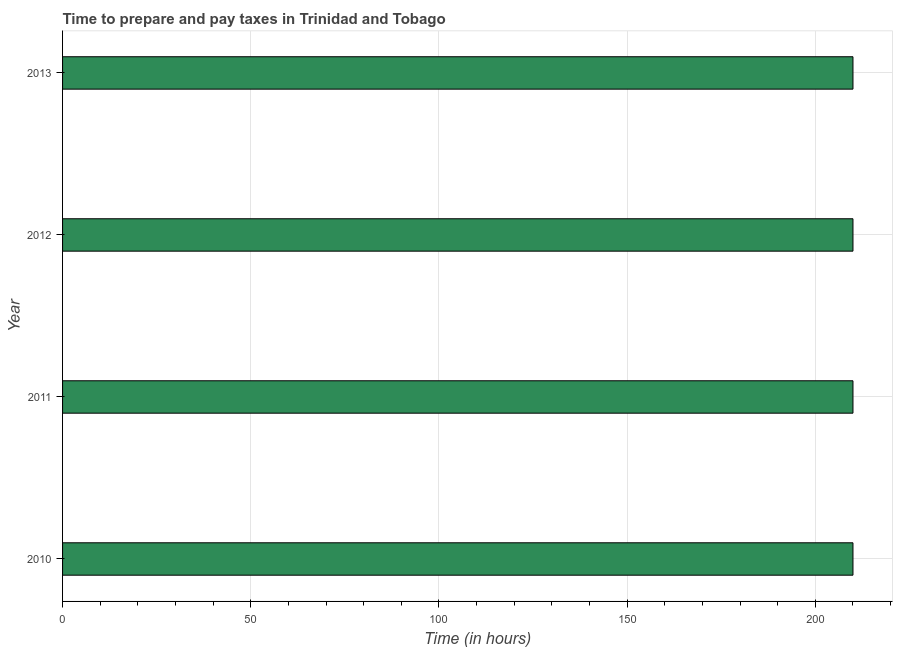Does the graph contain any zero values?
Keep it short and to the point. No. Does the graph contain grids?
Provide a short and direct response. Yes. What is the title of the graph?
Ensure brevity in your answer.  Time to prepare and pay taxes in Trinidad and Tobago. What is the label or title of the X-axis?
Ensure brevity in your answer.  Time (in hours). What is the label or title of the Y-axis?
Provide a succinct answer. Year. What is the time to prepare and pay taxes in 2012?
Make the answer very short. 210. Across all years, what is the maximum time to prepare and pay taxes?
Give a very brief answer. 210. Across all years, what is the minimum time to prepare and pay taxes?
Keep it short and to the point. 210. In which year was the time to prepare and pay taxes maximum?
Give a very brief answer. 2010. In which year was the time to prepare and pay taxes minimum?
Keep it short and to the point. 2010. What is the sum of the time to prepare and pay taxes?
Provide a short and direct response. 840. What is the difference between the time to prepare and pay taxes in 2011 and 2012?
Your response must be concise. 0. What is the average time to prepare and pay taxes per year?
Your answer should be compact. 210. What is the median time to prepare and pay taxes?
Make the answer very short. 210. What is the ratio of the time to prepare and pay taxes in 2011 to that in 2012?
Offer a very short reply. 1. Is the difference between the time to prepare and pay taxes in 2012 and 2013 greater than the difference between any two years?
Provide a succinct answer. Yes. In how many years, is the time to prepare and pay taxes greater than the average time to prepare and pay taxes taken over all years?
Offer a terse response. 0. How many bars are there?
Give a very brief answer. 4. How many years are there in the graph?
Offer a terse response. 4. What is the difference between two consecutive major ticks on the X-axis?
Your answer should be very brief. 50. Are the values on the major ticks of X-axis written in scientific E-notation?
Give a very brief answer. No. What is the Time (in hours) of 2010?
Offer a terse response. 210. What is the Time (in hours) of 2011?
Your response must be concise. 210. What is the Time (in hours) in 2012?
Your answer should be very brief. 210. What is the Time (in hours) of 2013?
Offer a terse response. 210. What is the difference between the Time (in hours) in 2010 and 2012?
Your answer should be very brief. 0. What is the difference between the Time (in hours) in 2010 and 2013?
Your response must be concise. 0. What is the difference between the Time (in hours) in 2011 and 2012?
Keep it short and to the point. 0. What is the ratio of the Time (in hours) in 2010 to that in 2012?
Offer a very short reply. 1. What is the ratio of the Time (in hours) in 2010 to that in 2013?
Offer a very short reply. 1. What is the ratio of the Time (in hours) in 2011 to that in 2012?
Provide a short and direct response. 1. What is the ratio of the Time (in hours) in 2011 to that in 2013?
Your answer should be very brief. 1. 